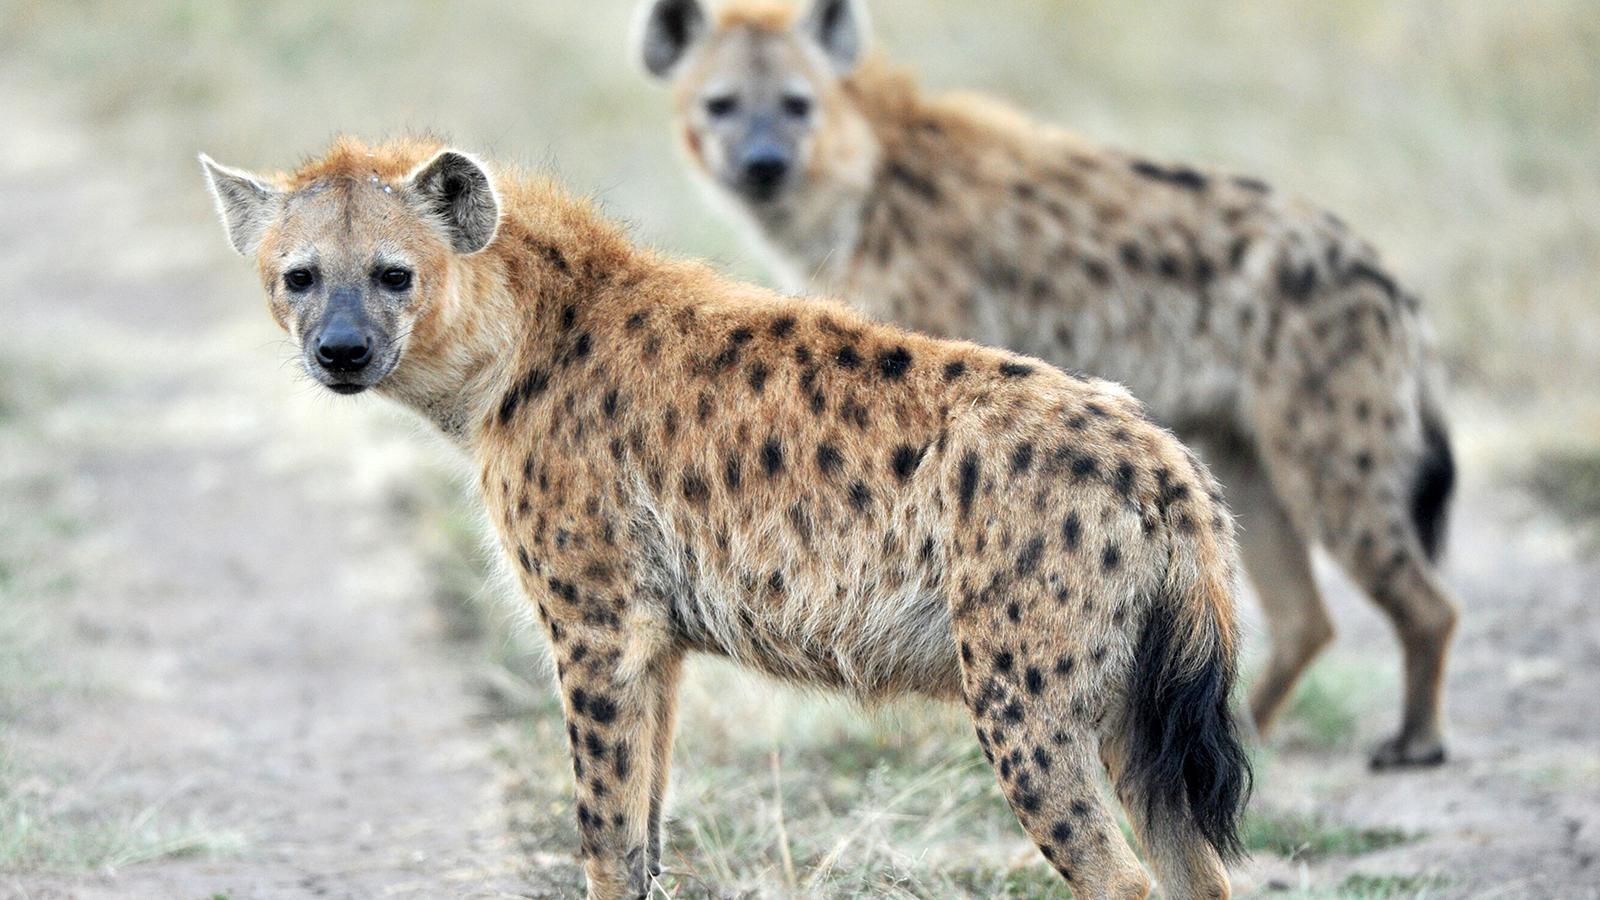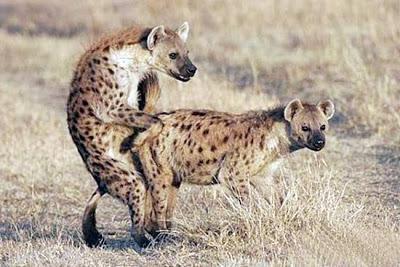The first image is the image on the left, the second image is the image on the right. Evaluate the accuracy of this statement regarding the images: "There are four hyenas in the image pair.". Is it true? Answer yes or no. Yes. The first image is the image on the left, the second image is the image on the right. Evaluate the accuracy of this statement regarding the images: "The animal in the image on the left is lying on the ground.". Is it true? Answer yes or no. No. 